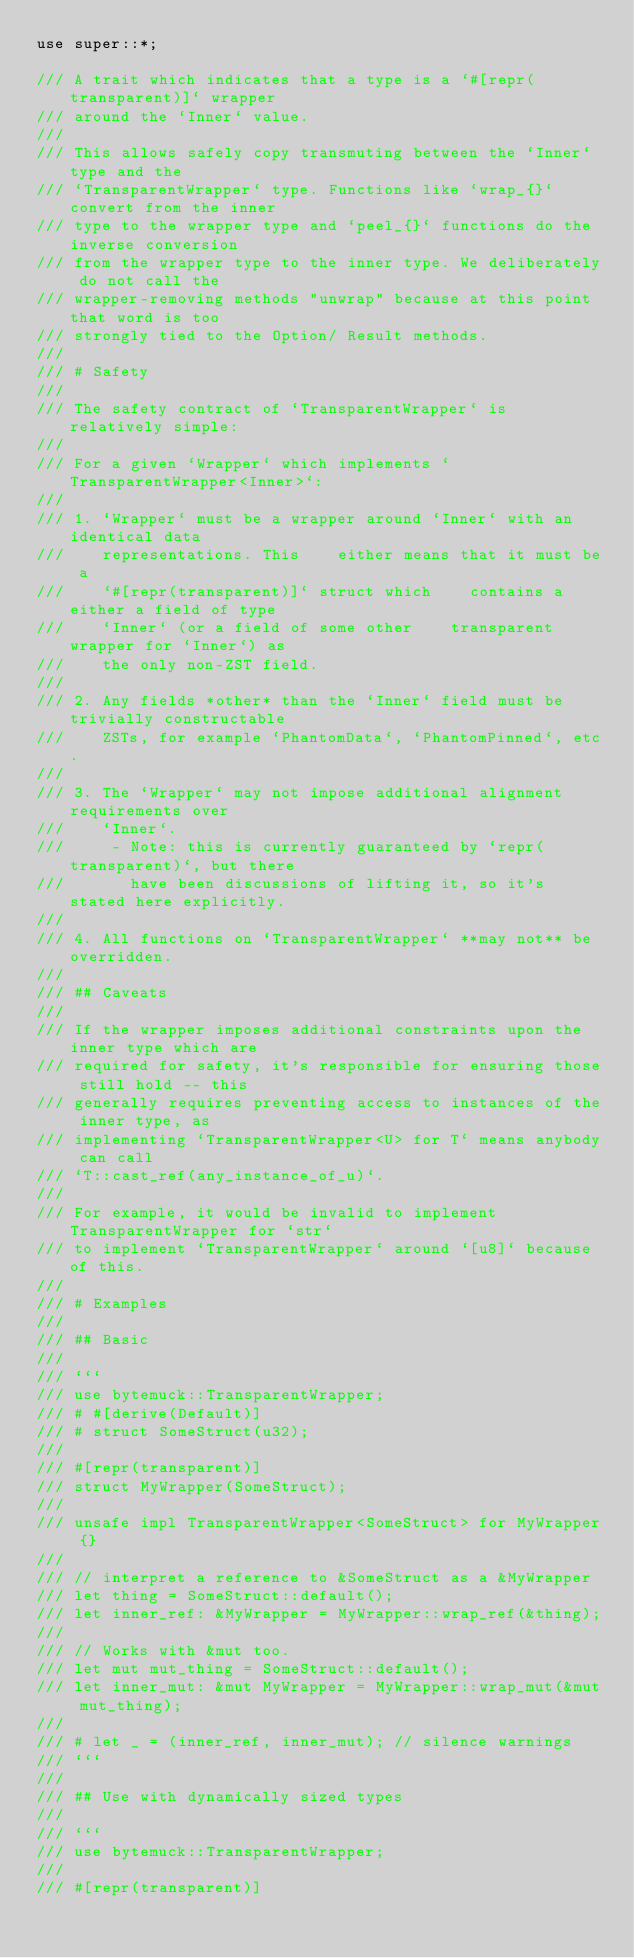Convert code to text. <code><loc_0><loc_0><loc_500><loc_500><_Rust_>use super::*;

/// A trait which indicates that a type is a `#[repr(transparent)]` wrapper
/// around the `Inner` value.
///
/// This allows safely copy transmuting between the `Inner` type and the
/// `TransparentWrapper` type. Functions like `wrap_{}` convert from the inner
/// type to the wrapper type and `peel_{}` functions do the inverse conversion
/// from the wrapper type to the inner type. We deliberately do not call the
/// wrapper-removing methods "unwrap" because at this point that word is too
/// strongly tied to the Option/ Result methods.
///
/// # Safety
///
/// The safety contract of `TransparentWrapper` is relatively simple:
///
/// For a given `Wrapper` which implements `TransparentWrapper<Inner>`:
///
/// 1. `Wrapper` must be a wrapper around `Inner` with an identical data
///    representations. This    either means that it must be a
///    `#[repr(transparent)]` struct which    contains a either a field of type
///    `Inner` (or a field of some other    transparent wrapper for `Inner`) as
///    the only non-ZST field.
///
/// 2. Any fields *other* than the `Inner` field must be trivially constructable
///    ZSTs, for example `PhantomData`, `PhantomPinned`, etc.
///
/// 3. The `Wrapper` may not impose additional alignment requirements over
///    `Inner`.
///     - Note: this is currently guaranteed by `repr(transparent)`, but there
///       have been discussions of lifting it, so it's stated here explicitly.
///
/// 4. All functions on `TransparentWrapper` **may not** be overridden.
///
/// ## Caveats
///
/// If the wrapper imposes additional constraints upon the inner type which are
/// required for safety, it's responsible for ensuring those still hold -- this
/// generally requires preventing access to instances of the inner type, as
/// implementing `TransparentWrapper<U> for T` means anybody can call
/// `T::cast_ref(any_instance_of_u)`.
///
/// For example, it would be invalid to implement TransparentWrapper for `str`
/// to implement `TransparentWrapper` around `[u8]` because of this.
///
/// # Examples
///
/// ## Basic
///
/// ```
/// use bytemuck::TransparentWrapper;
/// # #[derive(Default)]
/// # struct SomeStruct(u32);
///
/// #[repr(transparent)]
/// struct MyWrapper(SomeStruct);
///
/// unsafe impl TransparentWrapper<SomeStruct> for MyWrapper {}
///
/// // interpret a reference to &SomeStruct as a &MyWrapper
/// let thing = SomeStruct::default();
/// let inner_ref: &MyWrapper = MyWrapper::wrap_ref(&thing);
///
/// // Works with &mut too.
/// let mut mut_thing = SomeStruct::default();
/// let inner_mut: &mut MyWrapper = MyWrapper::wrap_mut(&mut mut_thing);
///
/// # let _ = (inner_ref, inner_mut); // silence warnings
/// ```
///
/// ## Use with dynamically sized types
///
/// ```
/// use bytemuck::TransparentWrapper;
///
/// #[repr(transparent)]</code> 